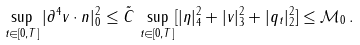<formula> <loc_0><loc_0><loc_500><loc_500>\sup _ { t \in [ 0 , T ] } | \partial ^ { 4 } v \cdot n | _ { 0 } ^ { 2 } \leq \tilde { C } \, \sup _ { t \in [ 0 , T ] } [ | \eta | _ { 4 } ^ { 2 } + | v | _ { 3 } ^ { 2 } + | q _ { t } | _ { 2 } ^ { 2 } ] \leq { \mathcal { M } } _ { 0 } \, .</formula> 